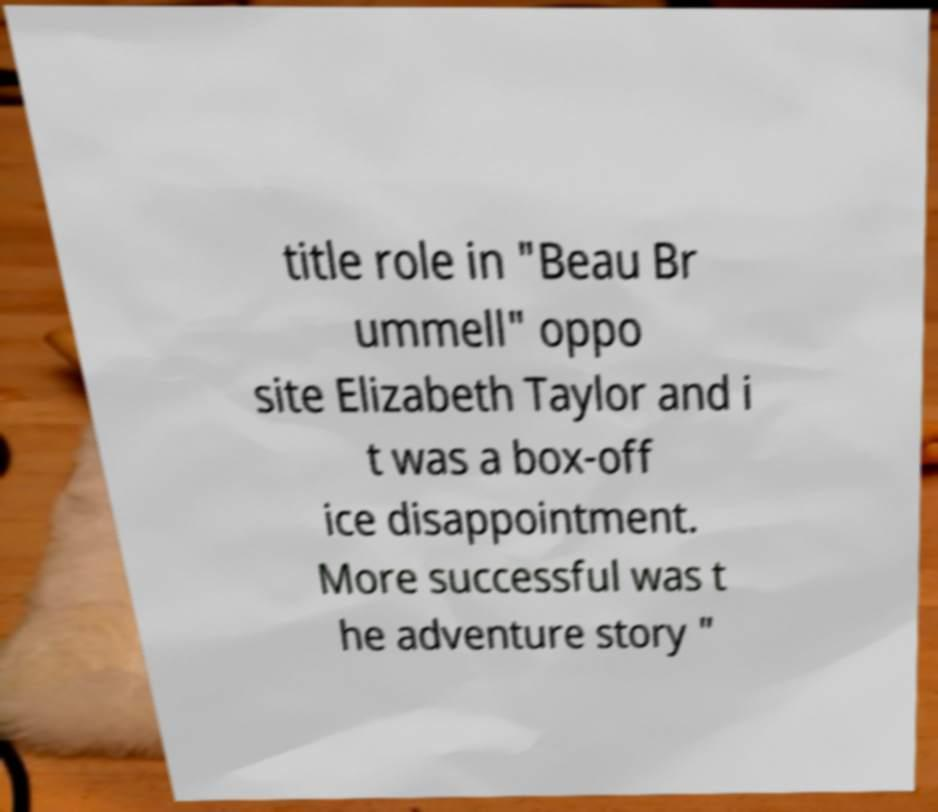For documentation purposes, I need the text within this image transcribed. Could you provide that? title role in "Beau Br ummell" oppo site Elizabeth Taylor and i t was a box-off ice disappointment. More successful was t he adventure story " 